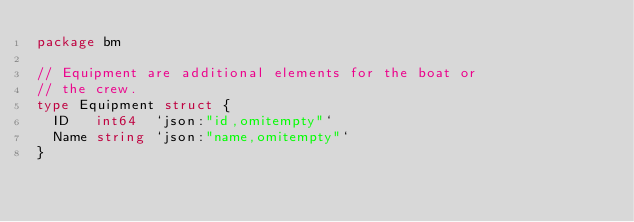<code> <loc_0><loc_0><loc_500><loc_500><_Go_>package bm

// Equipment are additional elements for the boat or
// the crew.
type Equipment struct {
	ID   int64  `json:"id,omitempty"`
	Name string `json:"name,omitempty"`
}
</code> 